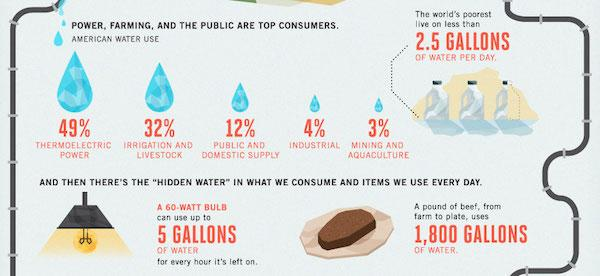List a handful of essential elements in this visual. The world's poorest individuals consume an average of 2.5 gallons of water per day, according to recent estimates. It is estimated that a 60W bulb used for 5 hours would consume approximately 5 gallons of water. It is estimated that a pound of beef requires approximately 1,800 gallons of water to produce. According to recent studies, the mining and aquaculture sector accounts for only 3% of the total water consumption worldwide. The industrial sector consumes 4% of water. 